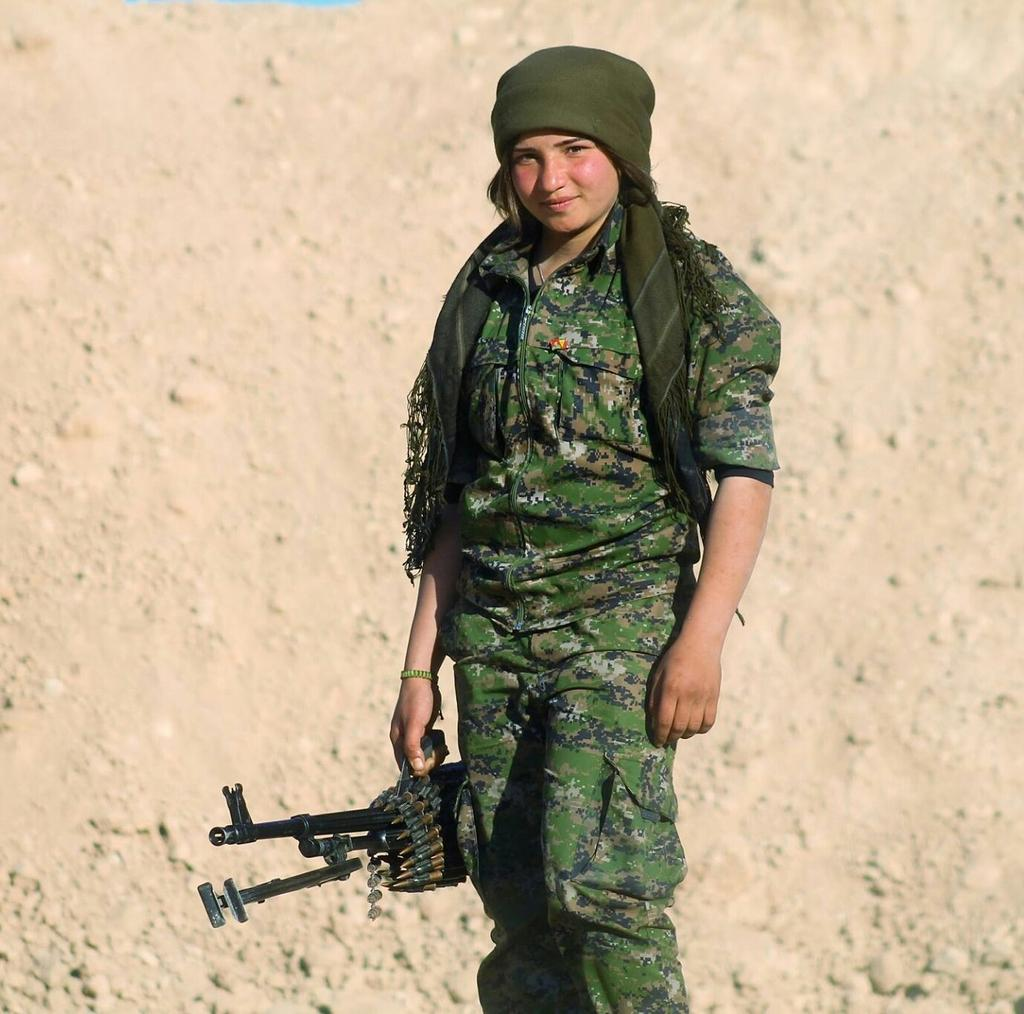What is the main subject of the image? There is a person in the image. What type of clothing is the person wearing? The person is wearing military dress. What object is the person holding? The person is holding a weapon. Can you describe the background of the image? The background of the image is cream-colored. What type of sail can be seen on the person's clothing in the image? There is no sail present on the person's clothing in the image; they are wearing military dress. What kind of beast is interacting with the person in the image? There is no beast present in the image; the person is the main subject. 